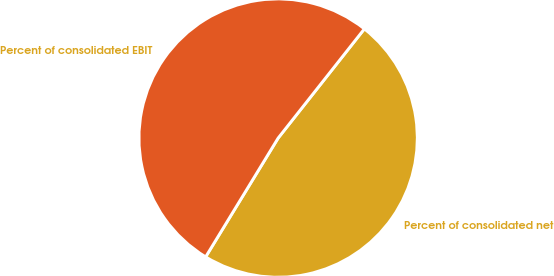Convert chart to OTSL. <chart><loc_0><loc_0><loc_500><loc_500><pie_chart><fcel>Percent of consolidated net<fcel>Percent of consolidated EBIT<nl><fcel>48.08%<fcel>51.92%<nl></chart> 